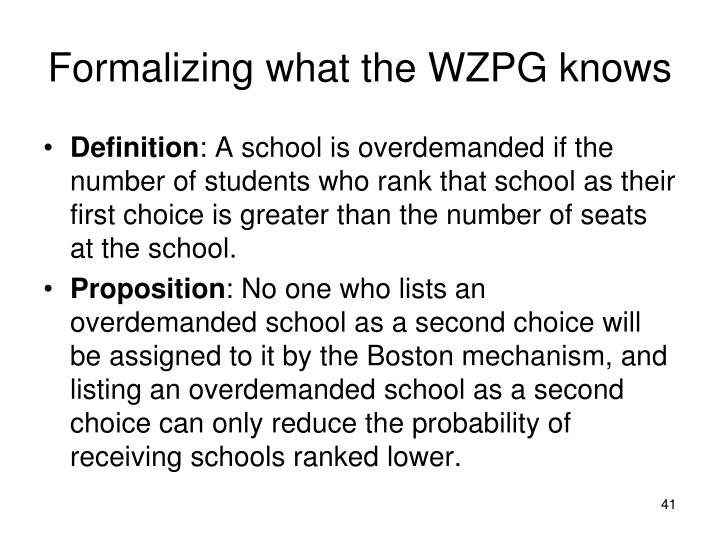How does the Boston mechanism affect students' strategic choices if a student's first choice is also overdemanded? In the context of the Boston mechanism, if a student's first choice is an overdemanded school, the student's chances of acceptance mainly depend on the lottery system used for seat allocation. However, if not selected, the same logic applies: putting another overdemanded school as a second choice further diminishes the chances for lower preferences. Hence, students may want to prioritize schools where demand aligns more closely with available seats for subsequent choices, after an overdemanded first choice. 